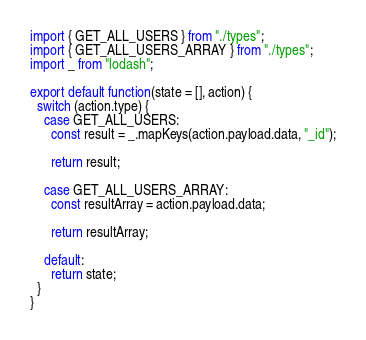<code> <loc_0><loc_0><loc_500><loc_500><_JavaScript_>import { GET_ALL_USERS } from "./types";
import { GET_ALL_USERS_ARRAY } from "./types";
import _ from "lodash";

export default function(state = [], action) {
  switch (action.type) {
    case GET_ALL_USERS:
      const result = _.mapKeys(action.payload.data, "_id");

      return result;

    case GET_ALL_USERS_ARRAY:
      const resultArray = action.payload.data;

      return resultArray;

    default:
      return state;
  }
}
</code> 